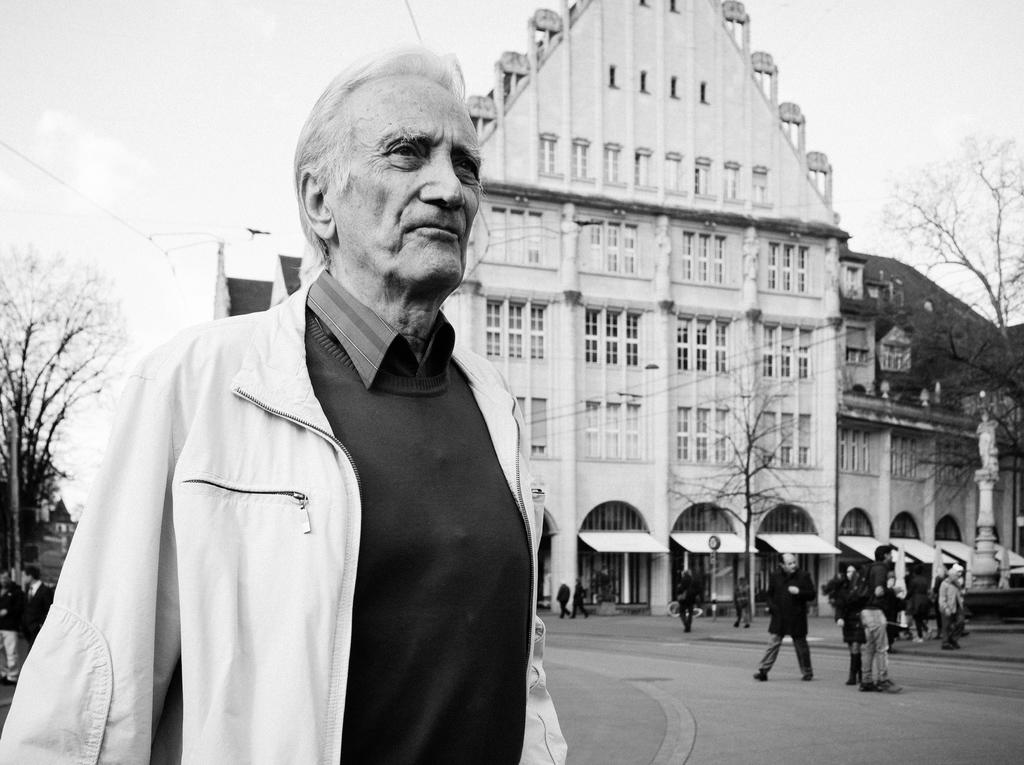What is the main feature of the image? There is a road in the image. Are there any people in the image? Yes, there are people in the image. What objects are present to provide shade? Sunshades are present in the image. What type of natural elements can be seen in the image? There are trees in the image. Can you describe the building in the image? There is a building with windows in the image. What is visible in the background of the image? The sky is visible in the background of the image. Where is the kettle located in the image? There is no kettle present in the image. What type of map can be seen in the image? There is no map present in the image. 